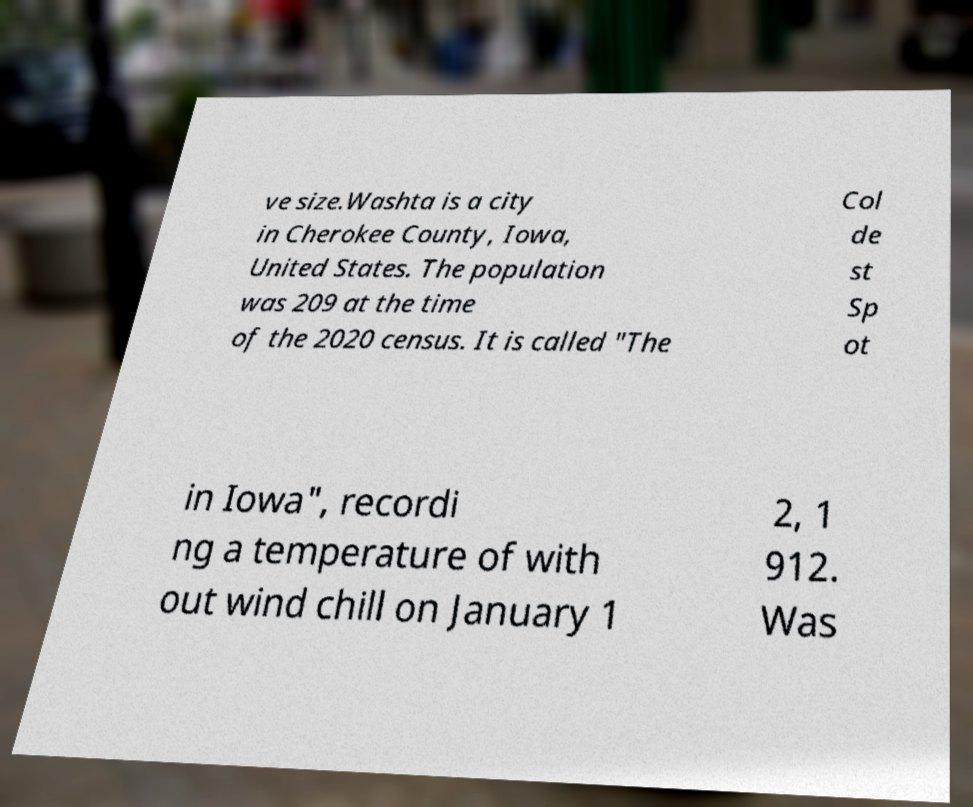Can you accurately transcribe the text from the provided image for me? ve size.Washta is a city in Cherokee County, Iowa, United States. The population was 209 at the time of the 2020 census. It is called "The Col de st Sp ot in Iowa", recordi ng a temperature of with out wind chill on January 1 2, 1 912. Was 